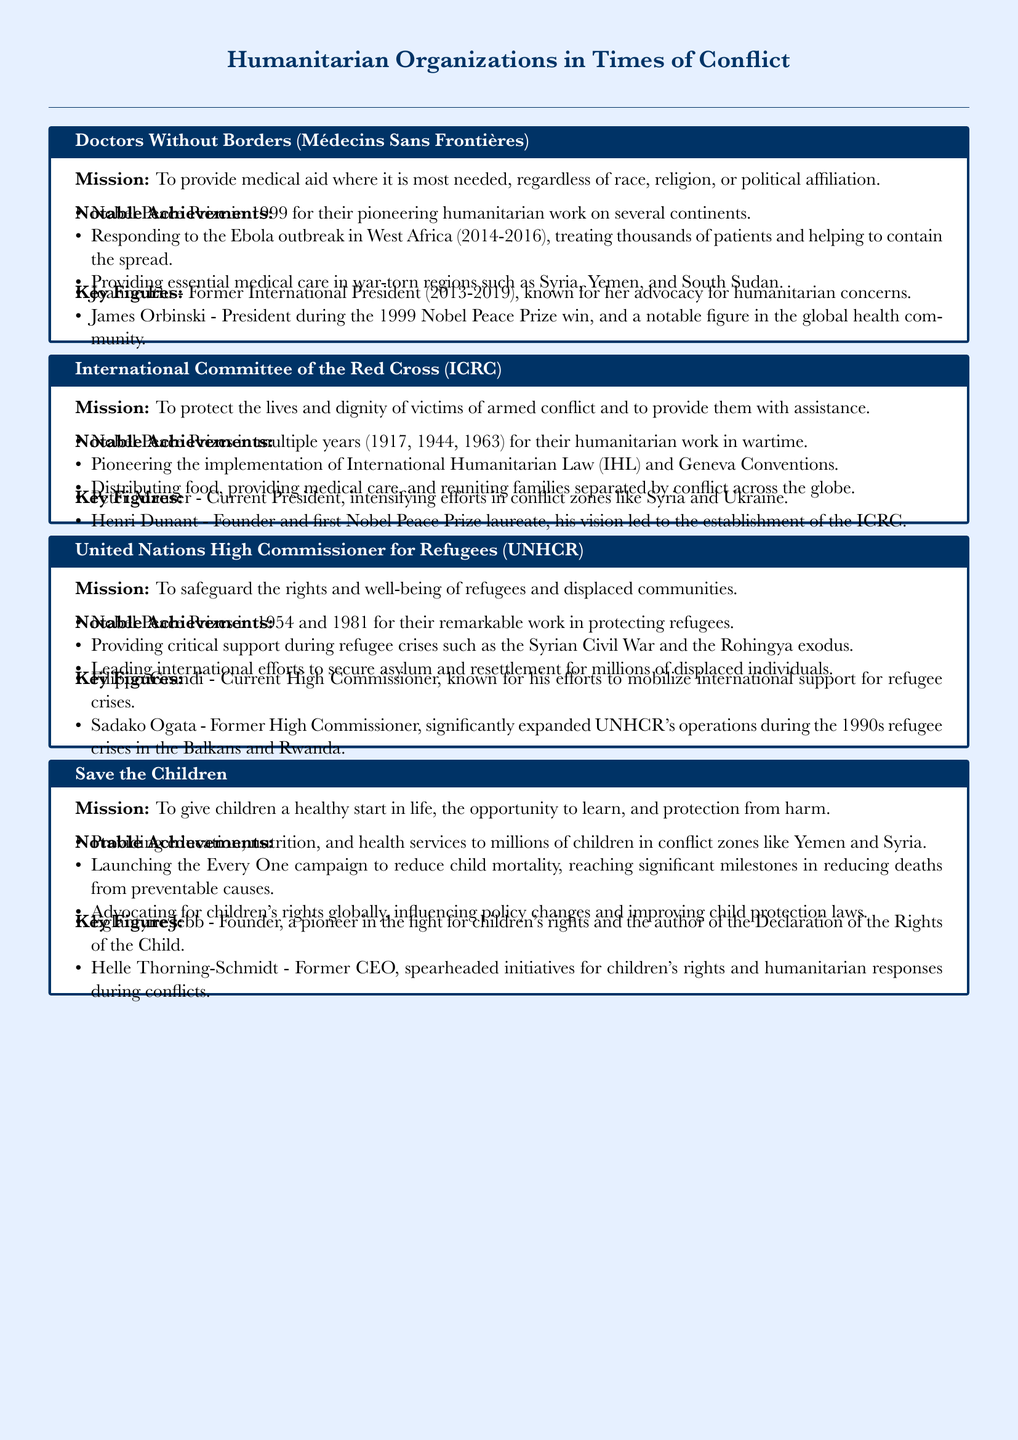What is the mission of Doctors Without Borders? The mission describes their intention to provide medical aid without bias to race, religion, or political affiliation.
Answer: To provide medical aid where it is most needed, regardless of race, religion, or political affiliation Who was the former International President of Doctors Without Borders? The document lists Joanne Liu as the former International President who served from 2013 to 2019.
Answer: Joanne Liu How many Nobel Peace Prizes has the International Committee of the Red Cross won? The document states they have been awarded Nobel Peace Prizes in multiple years, specifically mentioning 1917, 1944, and 1963.
Answer: Three What significant event did the UNHCR respond to during the Syrian Civil War? The document mentions the UNHCR provided critical support during the refugee crises emerging from the Syrian Civil War.
Answer: Syrian Civil War Who founded Save the Children? The document attributes the founding of Save the Children to a notable figure in children's rights.
Answer: Eglantyne Jebb What is the notable campaign launched by Save the Children? The document refers to the 'Every One' campaign aimed at reducing child mortality.
Answer: Every One Who is the current High Commissioner for UNHCR? Filippo Grandi is identified in the document as the Current High Commissioner of UNHCR.
Answer: Filippo Grandi What landmark legal framework did the International Committee of the Red Cross help implement? The document states that the ICRC pioneered the implementation of International Humanitarian Law.
Answer: International Humanitarian Law Which humanitarian organization was founded by Henri Dunant? The document states that Henri Dunant is identified as the founder of the International Committee of the Red Cross.
Answer: International Committee of the Red Cross 